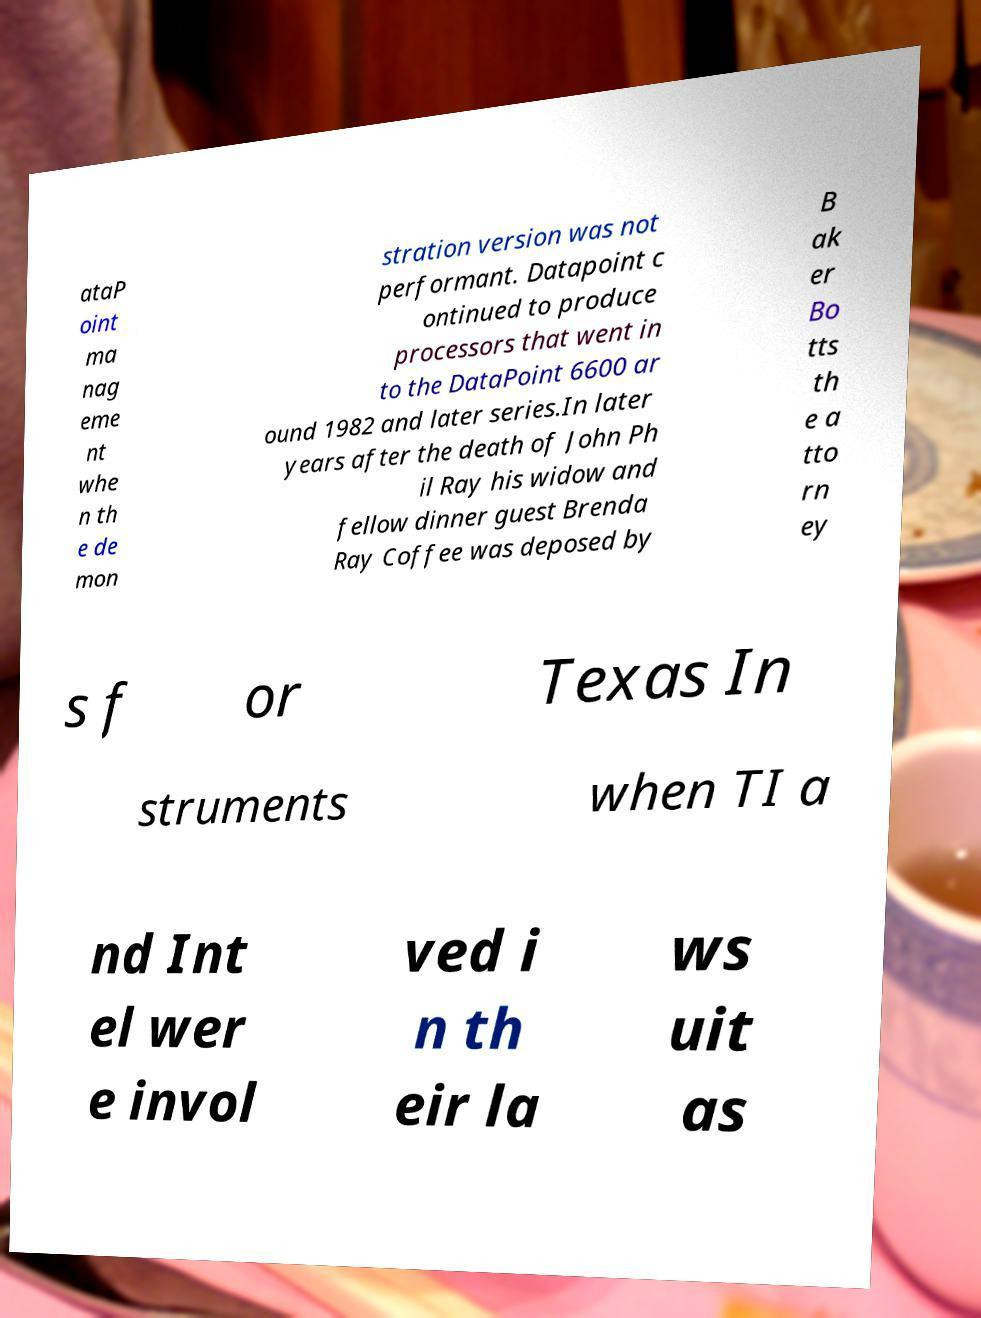There's text embedded in this image that I need extracted. Can you transcribe it verbatim? ataP oint ma nag eme nt whe n th e de mon stration version was not performant. Datapoint c ontinued to produce processors that went in to the DataPoint 6600 ar ound 1982 and later series.In later years after the death of John Ph il Ray his widow and fellow dinner guest Brenda Ray Coffee was deposed by B ak er Bo tts th e a tto rn ey s f or Texas In struments when TI a nd Int el wer e invol ved i n th eir la ws uit as 